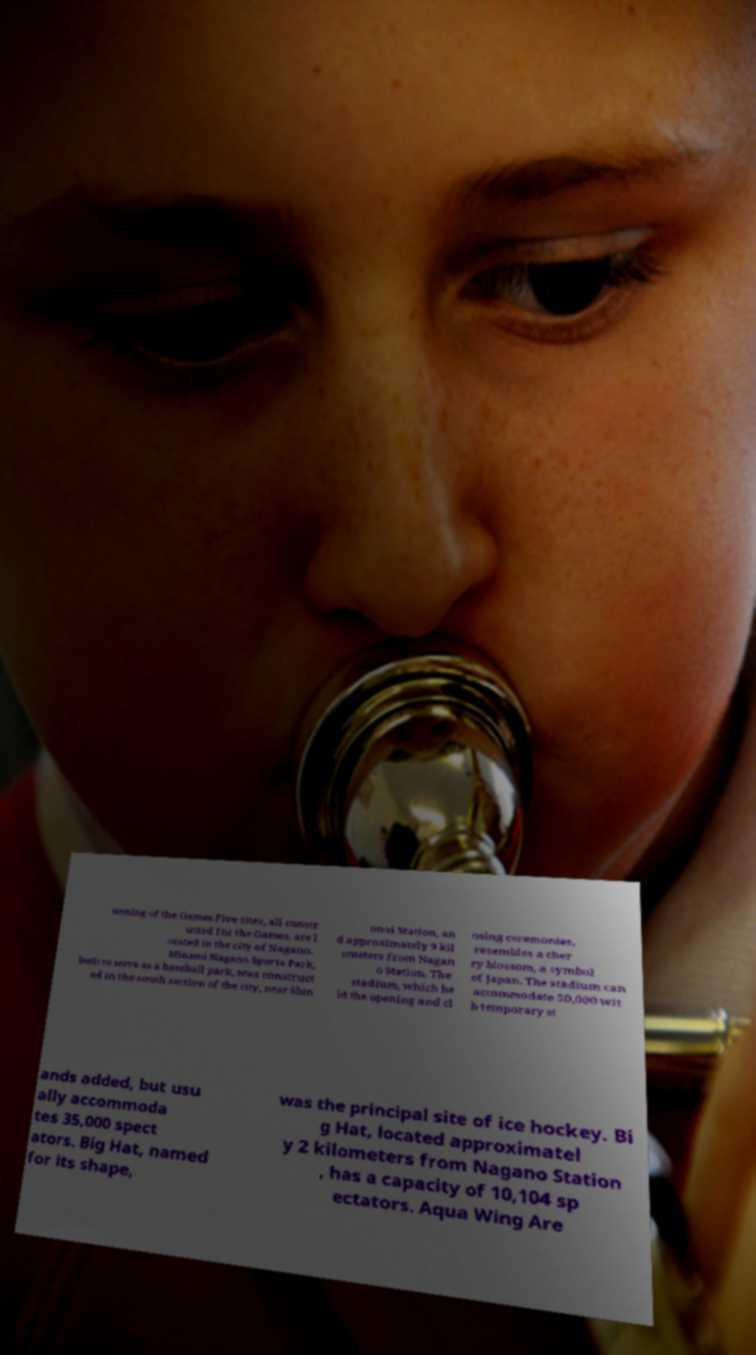Could you extract and type out the text from this image? unning of the Games.Five sites, all constr ucted for the Games, are l ocated in the city of Nagano. Minami Nagano Sports Park, built to serve as a baseball park, was construct ed in the south section of the city, near Shin onoi Station, an d approximately 9 kil ometers from Nagan o Station. The stadium, which he ld the opening and cl osing ceremonies, resembles a cher ry blossom, a symbol of Japan. The stadium can accommodate 50,000 wit h temporary st ands added, but usu ally accommoda tes 35,000 spect ators. Big Hat, named for its shape, was the principal site of ice hockey. Bi g Hat, located approximatel y 2 kilometers from Nagano Station , has a capacity of 10,104 sp ectators. Aqua Wing Are 